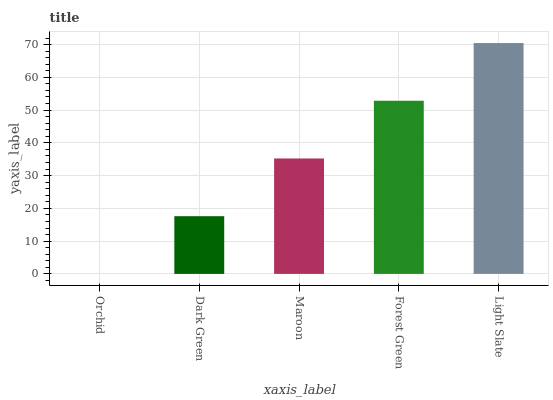Is Orchid the minimum?
Answer yes or no. Yes. Is Light Slate the maximum?
Answer yes or no. Yes. Is Dark Green the minimum?
Answer yes or no. No. Is Dark Green the maximum?
Answer yes or no. No. Is Dark Green greater than Orchid?
Answer yes or no. Yes. Is Orchid less than Dark Green?
Answer yes or no. Yes. Is Orchid greater than Dark Green?
Answer yes or no. No. Is Dark Green less than Orchid?
Answer yes or no. No. Is Maroon the high median?
Answer yes or no. Yes. Is Maroon the low median?
Answer yes or no. Yes. Is Orchid the high median?
Answer yes or no. No. Is Orchid the low median?
Answer yes or no. No. 